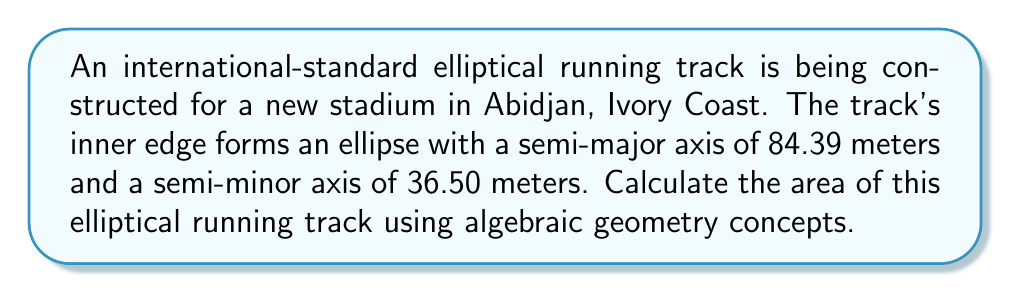Could you help me with this problem? Let's approach this step-by-step using algebraic geometry:

1) The general equation of an ellipse centered at the origin is:

   $$\frac{x^2}{a^2} + \frac{y^2}{b^2} = 1$$

   where $a$ is the semi-major axis and $b$ is the semi-minor axis.

2) In this case, $a = 84.39$ m and $b = 36.50$ m.

3) The area of an ellipse is given by the formula:

   $$A = \pi ab$$

4) Substituting our values:

   $$A = \pi(84.39)(36.50)$$

5) Simplifying:

   $$A = 9661.9865\pi$$

6) Calculating the final value:

   $$A \approx 30,360.07 \text{ m}^2$$

This result can be verified using algebraic geometry techniques. The area of an ellipse can be derived by integrating the equation of the ellipse in polar form:

$$r(\theta) = \frac{ab}{\sqrt{(b\cos\theta)^2 + (a\sin\theta)^2}}$$

The area is then given by:

$$A = \int_0^{2\pi} \frac{1}{2}r(\theta)^2 d\theta$$

Which, when evaluated, yields the same result: $\pi ab$.
Answer: $30,360.07 \text{ m}^2$ 